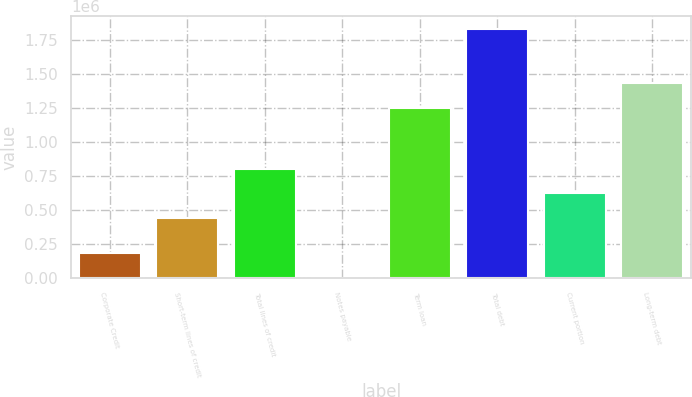Convert chart to OTSL. <chart><loc_0><loc_0><loc_500><loc_500><bar_chart><fcel>Corporate Credit<fcel>Short-term lines of credit<fcel>Total lines of credit<fcel>Notes payable<fcel>Term loan<fcel>Total debt<fcel>Current portion<fcel>Long-term debt<nl><fcel>186692<fcel>440128<fcel>806154<fcel>3679<fcel>1.25e+06<fcel>1.83381e+06<fcel>623141<fcel>1.43301e+06<nl></chart> 